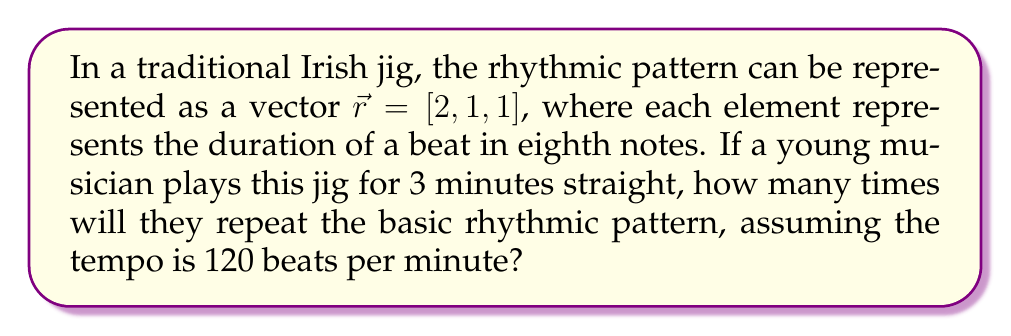Can you solve this math problem? Let's approach this step-by-step:

1) First, we need to calculate the total number of beats in the rhythmic pattern:
   $$\text{Total beats} = \sum_{i=1}^{3} r_i = 2 + 1 + 1 = 4$$

2) Now, let's calculate how many eighth notes are in 3 minutes at 120 beats per minute:
   $$\text{Eighth notes per minute} = 120 \times 2 = 240$$
   $$\text{Total eighth notes in 3 minutes} = 240 \times 3 = 720$$

3) To find how many times the pattern repeats, we divide the total eighth notes by the number of eighth notes in one pattern:
   $$\text{Number of repetitions} = \frac{\text{Total eighth notes}}{\text{Eighth notes per pattern}}$$
   $$= \frac{720}{4} = 180$$

Therefore, the young musician will repeat the basic rhythmic pattern 180 times in 3 minutes.
Answer: 180 repetitions 